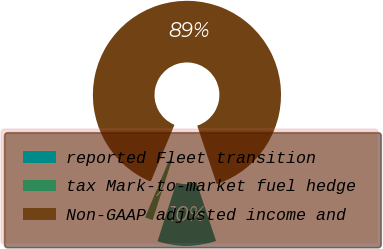<chart> <loc_0><loc_0><loc_500><loc_500><pie_chart><fcel>reported Fleet transition<fcel>tax Mark-to-market fuel hedge<fcel>Non-GAAP adjusted income and<nl><fcel>10.07%<fcel>1.35%<fcel>88.58%<nl></chart> 